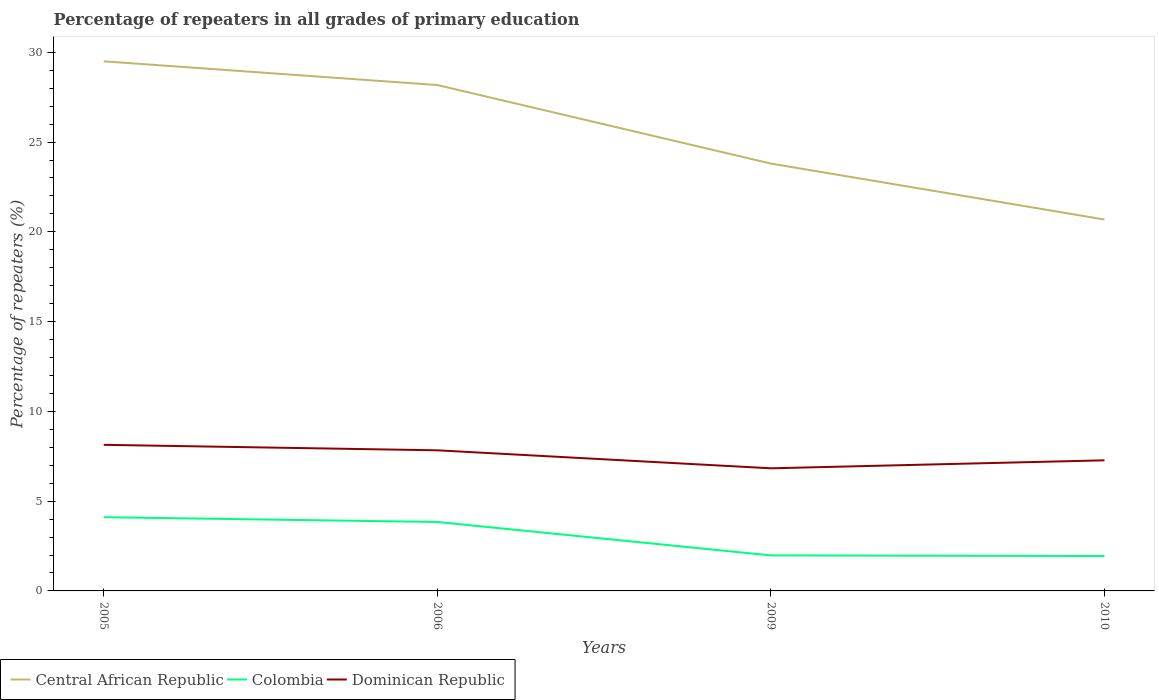Across all years, what is the maximum percentage of repeaters in Dominican Republic?
Offer a terse response. 6.83. What is the total percentage of repeaters in Central African Republic in the graph?
Offer a very short reply. 4.37. What is the difference between the highest and the second highest percentage of repeaters in Dominican Republic?
Offer a terse response. 1.31. What is the difference between the highest and the lowest percentage of repeaters in Central African Republic?
Offer a very short reply. 2. How many years are there in the graph?
Your answer should be compact. 4. What is the difference between two consecutive major ticks on the Y-axis?
Ensure brevity in your answer.  5. How are the legend labels stacked?
Make the answer very short. Horizontal. What is the title of the graph?
Keep it short and to the point. Percentage of repeaters in all grades of primary education. Does "Panama" appear as one of the legend labels in the graph?
Offer a terse response. No. What is the label or title of the X-axis?
Ensure brevity in your answer.  Years. What is the label or title of the Y-axis?
Keep it short and to the point. Percentage of repeaters (%). What is the Percentage of repeaters (%) in Central African Republic in 2005?
Your answer should be very brief. 29.5. What is the Percentage of repeaters (%) of Colombia in 2005?
Provide a short and direct response. 4.11. What is the Percentage of repeaters (%) of Dominican Republic in 2005?
Ensure brevity in your answer.  8.14. What is the Percentage of repeaters (%) of Central African Republic in 2006?
Your response must be concise. 28.18. What is the Percentage of repeaters (%) of Colombia in 2006?
Your answer should be compact. 3.84. What is the Percentage of repeaters (%) of Dominican Republic in 2006?
Your answer should be very brief. 7.83. What is the Percentage of repeaters (%) of Central African Republic in 2009?
Offer a terse response. 23.8. What is the Percentage of repeaters (%) of Colombia in 2009?
Your response must be concise. 1.98. What is the Percentage of repeaters (%) of Dominican Republic in 2009?
Offer a very short reply. 6.83. What is the Percentage of repeaters (%) of Central African Republic in 2010?
Your response must be concise. 20.69. What is the Percentage of repeaters (%) of Colombia in 2010?
Offer a very short reply. 1.94. What is the Percentage of repeaters (%) in Dominican Republic in 2010?
Keep it short and to the point. 7.27. Across all years, what is the maximum Percentage of repeaters (%) in Central African Republic?
Give a very brief answer. 29.5. Across all years, what is the maximum Percentage of repeaters (%) in Colombia?
Give a very brief answer. 4.11. Across all years, what is the maximum Percentage of repeaters (%) in Dominican Republic?
Make the answer very short. 8.14. Across all years, what is the minimum Percentage of repeaters (%) in Central African Republic?
Give a very brief answer. 20.69. Across all years, what is the minimum Percentage of repeaters (%) in Colombia?
Provide a short and direct response. 1.94. Across all years, what is the minimum Percentage of repeaters (%) in Dominican Republic?
Your response must be concise. 6.83. What is the total Percentage of repeaters (%) of Central African Republic in the graph?
Ensure brevity in your answer.  102.17. What is the total Percentage of repeaters (%) in Colombia in the graph?
Make the answer very short. 11.87. What is the total Percentage of repeaters (%) of Dominican Republic in the graph?
Offer a very short reply. 30.07. What is the difference between the Percentage of repeaters (%) of Central African Republic in 2005 and that in 2006?
Give a very brief answer. 1.32. What is the difference between the Percentage of repeaters (%) of Colombia in 2005 and that in 2006?
Keep it short and to the point. 0.27. What is the difference between the Percentage of repeaters (%) in Dominican Republic in 2005 and that in 2006?
Your answer should be compact. 0.3. What is the difference between the Percentage of repeaters (%) of Central African Republic in 2005 and that in 2009?
Your answer should be compact. 5.7. What is the difference between the Percentage of repeaters (%) in Colombia in 2005 and that in 2009?
Provide a short and direct response. 2.13. What is the difference between the Percentage of repeaters (%) of Dominican Republic in 2005 and that in 2009?
Make the answer very short. 1.31. What is the difference between the Percentage of repeaters (%) in Central African Republic in 2005 and that in 2010?
Provide a short and direct response. 8.81. What is the difference between the Percentage of repeaters (%) of Colombia in 2005 and that in 2010?
Your answer should be very brief. 2.16. What is the difference between the Percentage of repeaters (%) of Dominican Republic in 2005 and that in 2010?
Provide a short and direct response. 0.86. What is the difference between the Percentage of repeaters (%) in Central African Republic in 2006 and that in 2009?
Provide a succinct answer. 4.37. What is the difference between the Percentage of repeaters (%) in Colombia in 2006 and that in 2009?
Your answer should be compact. 1.86. What is the difference between the Percentage of repeaters (%) in Central African Republic in 2006 and that in 2010?
Ensure brevity in your answer.  7.49. What is the difference between the Percentage of repeaters (%) in Colombia in 2006 and that in 2010?
Make the answer very short. 1.9. What is the difference between the Percentage of repeaters (%) of Dominican Republic in 2006 and that in 2010?
Your answer should be compact. 0.56. What is the difference between the Percentage of repeaters (%) in Central African Republic in 2009 and that in 2010?
Keep it short and to the point. 3.12. What is the difference between the Percentage of repeaters (%) in Colombia in 2009 and that in 2010?
Make the answer very short. 0.03. What is the difference between the Percentage of repeaters (%) in Dominican Republic in 2009 and that in 2010?
Offer a terse response. -0.45. What is the difference between the Percentage of repeaters (%) of Central African Republic in 2005 and the Percentage of repeaters (%) of Colombia in 2006?
Make the answer very short. 25.66. What is the difference between the Percentage of repeaters (%) of Central African Republic in 2005 and the Percentage of repeaters (%) of Dominican Republic in 2006?
Your response must be concise. 21.67. What is the difference between the Percentage of repeaters (%) in Colombia in 2005 and the Percentage of repeaters (%) in Dominican Republic in 2006?
Your answer should be very brief. -3.73. What is the difference between the Percentage of repeaters (%) in Central African Republic in 2005 and the Percentage of repeaters (%) in Colombia in 2009?
Your answer should be compact. 27.52. What is the difference between the Percentage of repeaters (%) of Central African Republic in 2005 and the Percentage of repeaters (%) of Dominican Republic in 2009?
Make the answer very short. 22.67. What is the difference between the Percentage of repeaters (%) of Colombia in 2005 and the Percentage of repeaters (%) of Dominican Republic in 2009?
Your answer should be very brief. -2.72. What is the difference between the Percentage of repeaters (%) of Central African Republic in 2005 and the Percentage of repeaters (%) of Colombia in 2010?
Keep it short and to the point. 27.56. What is the difference between the Percentage of repeaters (%) of Central African Republic in 2005 and the Percentage of repeaters (%) of Dominican Republic in 2010?
Offer a very short reply. 22.22. What is the difference between the Percentage of repeaters (%) of Colombia in 2005 and the Percentage of repeaters (%) of Dominican Republic in 2010?
Ensure brevity in your answer.  -3.17. What is the difference between the Percentage of repeaters (%) of Central African Republic in 2006 and the Percentage of repeaters (%) of Colombia in 2009?
Give a very brief answer. 26.2. What is the difference between the Percentage of repeaters (%) of Central African Republic in 2006 and the Percentage of repeaters (%) of Dominican Republic in 2009?
Offer a terse response. 21.35. What is the difference between the Percentage of repeaters (%) in Colombia in 2006 and the Percentage of repeaters (%) in Dominican Republic in 2009?
Keep it short and to the point. -2.99. What is the difference between the Percentage of repeaters (%) of Central African Republic in 2006 and the Percentage of repeaters (%) of Colombia in 2010?
Offer a very short reply. 26.23. What is the difference between the Percentage of repeaters (%) of Central African Republic in 2006 and the Percentage of repeaters (%) of Dominican Republic in 2010?
Make the answer very short. 20.9. What is the difference between the Percentage of repeaters (%) of Colombia in 2006 and the Percentage of repeaters (%) of Dominican Republic in 2010?
Keep it short and to the point. -3.43. What is the difference between the Percentage of repeaters (%) in Central African Republic in 2009 and the Percentage of repeaters (%) in Colombia in 2010?
Offer a very short reply. 21.86. What is the difference between the Percentage of repeaters (%) of Central African Republic in 2009 and the Percentage of repeaters (%) of Dominican Republic in 2010?
Keep it short and to the point. 16.53. What is the difference between the Percentage of repeaters (%) of Colombia in 2009 and the Percentage of repeaters (%) of Dominican Republic in 2010?
Provide a short and direct response. -5.3. What is the average Percentage of repeaters (%) in Central African Republic per year?
Give a very brief answer. 25.54. What is the average Percentage of repeaters (%) in Colombia per year?
Make the answer very short. 2.97. What is the average Percentage of repeaters (%) in Dominican Republic per year?
Ensure brevity in your answer.  7.52. In the year 2005, what is the difference between the Percentage of repeaters (%) in Central African Republic and Percentage of repeaters (%) in Colombia?
Provide a succinct answer. 25.39. In the year 2005, what is the difference between the Percentage of repeaters (%) of Central African Republic and Percentage of repeaters (%) of Dominican Republic?
Offer a very short reply. 21.36. In the year 2005, what is the difference between the Percentage of repeaters (%) of Colombia and Percentage of repeaters (%) of Dominican Republic?
Give a very brief answer. -4.03. In the year 2006, what is the difference between the Percentage of repeaters (%) in Central African Republic and Percentage of repeaters (%) in Colombia?
Offer a very short reply. 24.34. In the year 2006, what is the difference between the Percentage of repeaters (%) of Central African Republic and Percentage of repeaters (%) of Dominican Republic?
Offer a terse response. 20.35. In the year 2006, what is the difference between the Percentage of repeaters (%) in Colombia and Percentage of repeaters (%) in Dominican Republic?
Give a very brief answer. -3.99. In the year 2009, what is the difference between the Percentage of repeaters (%) of Central African Republic and Percentage of repeaters (%) of Colombia?
Ensure brevity in your answer.  21.83. In the year 2009, what is the difference between the Percentage of repeaters (%) in Central African Republic and Percentage of repeaters (%) in Dominican Republic?
Your response must be concise. 16.97. In the year 2009, what is the difference between the Percentage of repeaters (%) in Colombia and Percentage of repeaters (%) in Dominican Republic?
Keep it short and to the point. -4.85. In the year 2010, what is the difference between the Percentage of repeaters (%) of Central African Republic and Percentage of repeaters (%) of Colombia?
Offer a very short reply. 18.74. In the year 2010, what is the difference between the Percentage of repeaters (%) of Central African Republic and Percentage of repeaters (%) of Dominican Republic?
Ensure brevity in your answer.  13.41. In the year 2010, what is the difference between the Percentage of repeaters (%) of Colombia and Percentage of repeaters (%) of Dominican Republic?
Your response must be concise. -5.33. What is the ratio of the Percentage of repeaters (%) in Central African Republic in 2005 to that in 2006?
Your answer should be compact. 1.05. What is the ratio of the Percentage of repeaters (%) of Colombia in 2005 to that in 2006?
Offer a terse response. 1.07. What is the ratio of the Percentage of repeaters (%) of Dominican Republic in 2005 to that in 2006?
Your answer should be very brief. 1.04. What is the ratio of the Percentage of repeaters (%) of Central African Republic in 2005 to that in 2009?
Give a very brief answer. 1.24. What is the ratio of the Percentage of repeaters (%) of Colombia in 2005 to that in 2009?
Make the answer very short. 2.08. What is the ratio of the Percentage of repeaters (%) in Dominican Republic in 2005 to that in 2009?
Provide a succinct answer. 1.19. What is the ratio of the Percentage of repeaters (%) of Central African Republic in 2005 to that in 2010?
Your response must be concise. 1.43. What is the ratio of the Percentage of repeaters (%) in Colombia in 2005 to that in 2010?
Keep it short and to the point. 2.11. What is the ratio of the Percentage of repeaters (%) of Dominican Republic in 2005 to that in 2010?
Your response must be concise. 1.12. What is the ratio of the Percentage of repeaters (%) in Central African Republic in 2006 to that in 2009?
Offer a terse response. 1.18. What is the ratio of the Percentage of repeaters (%) of Colombia in 2006 to that in 2009?
Provide a short and direct response. 1.94. What is the ratio of the Percentage of repeaters (%) in Dominican Republic in 2006 to that in 2009?
Provide a short and direct response. 1.15. What is the ratio of the Percentage of repeaters (%) in Central African Republic in 2006 to that in 2010?
Your answer should be very brief. 1.36. What is the ratio of the Percentage of repeaters (%) in Colombia in 2006 to that in 2010?
Offer a terse response. 1.98. What is the ratio of the Percentage of repeaters (%) in Dominican Republic in 2006 to that in 2010?
Offer a very short reply. 1.08. What is the ratio of the Percentage of repeaters (%) in Central African Republic in 2009 to that in 2010?
Your answer should be compact. 1.15. What is the ratio of the Percentage of repeaters (%) in Colombia in 2009 to that in 2010?
Provide a succinct answer. 1.02. What is the ratio of the Percentage of repeaters (%) of Dominican Republic in 2009 to that in 2010?
Ensure brevity in your answer.  0.94. What is the difference between the highest and the second highest Percentage of repeaters (%) in Central African Republic?
Your answer should be very brief. 1.32. What is the difference between the highest and the second highest Percentage of repeaters (%) of Colombia?
Provide a short and direct response. 0.27. What is the difference between the highest and the second highest Percentage of repeaters (%) in Dominican Republic?
Your response must be concise. 0.3. What is the difference between the highest and the lowest Percentage of repeaters (%) of Central African Republic?
Make the answer very short. 8.81. What is the difference between the highest and the lowest Percentage of repeaters (%) of Colombia?
Your answer should be very brief. 2.16. What is the difference between the highest and the lowest Percentage of repeaters (%) in Dominican Republic?
Your answer should be compact. 1.31. 